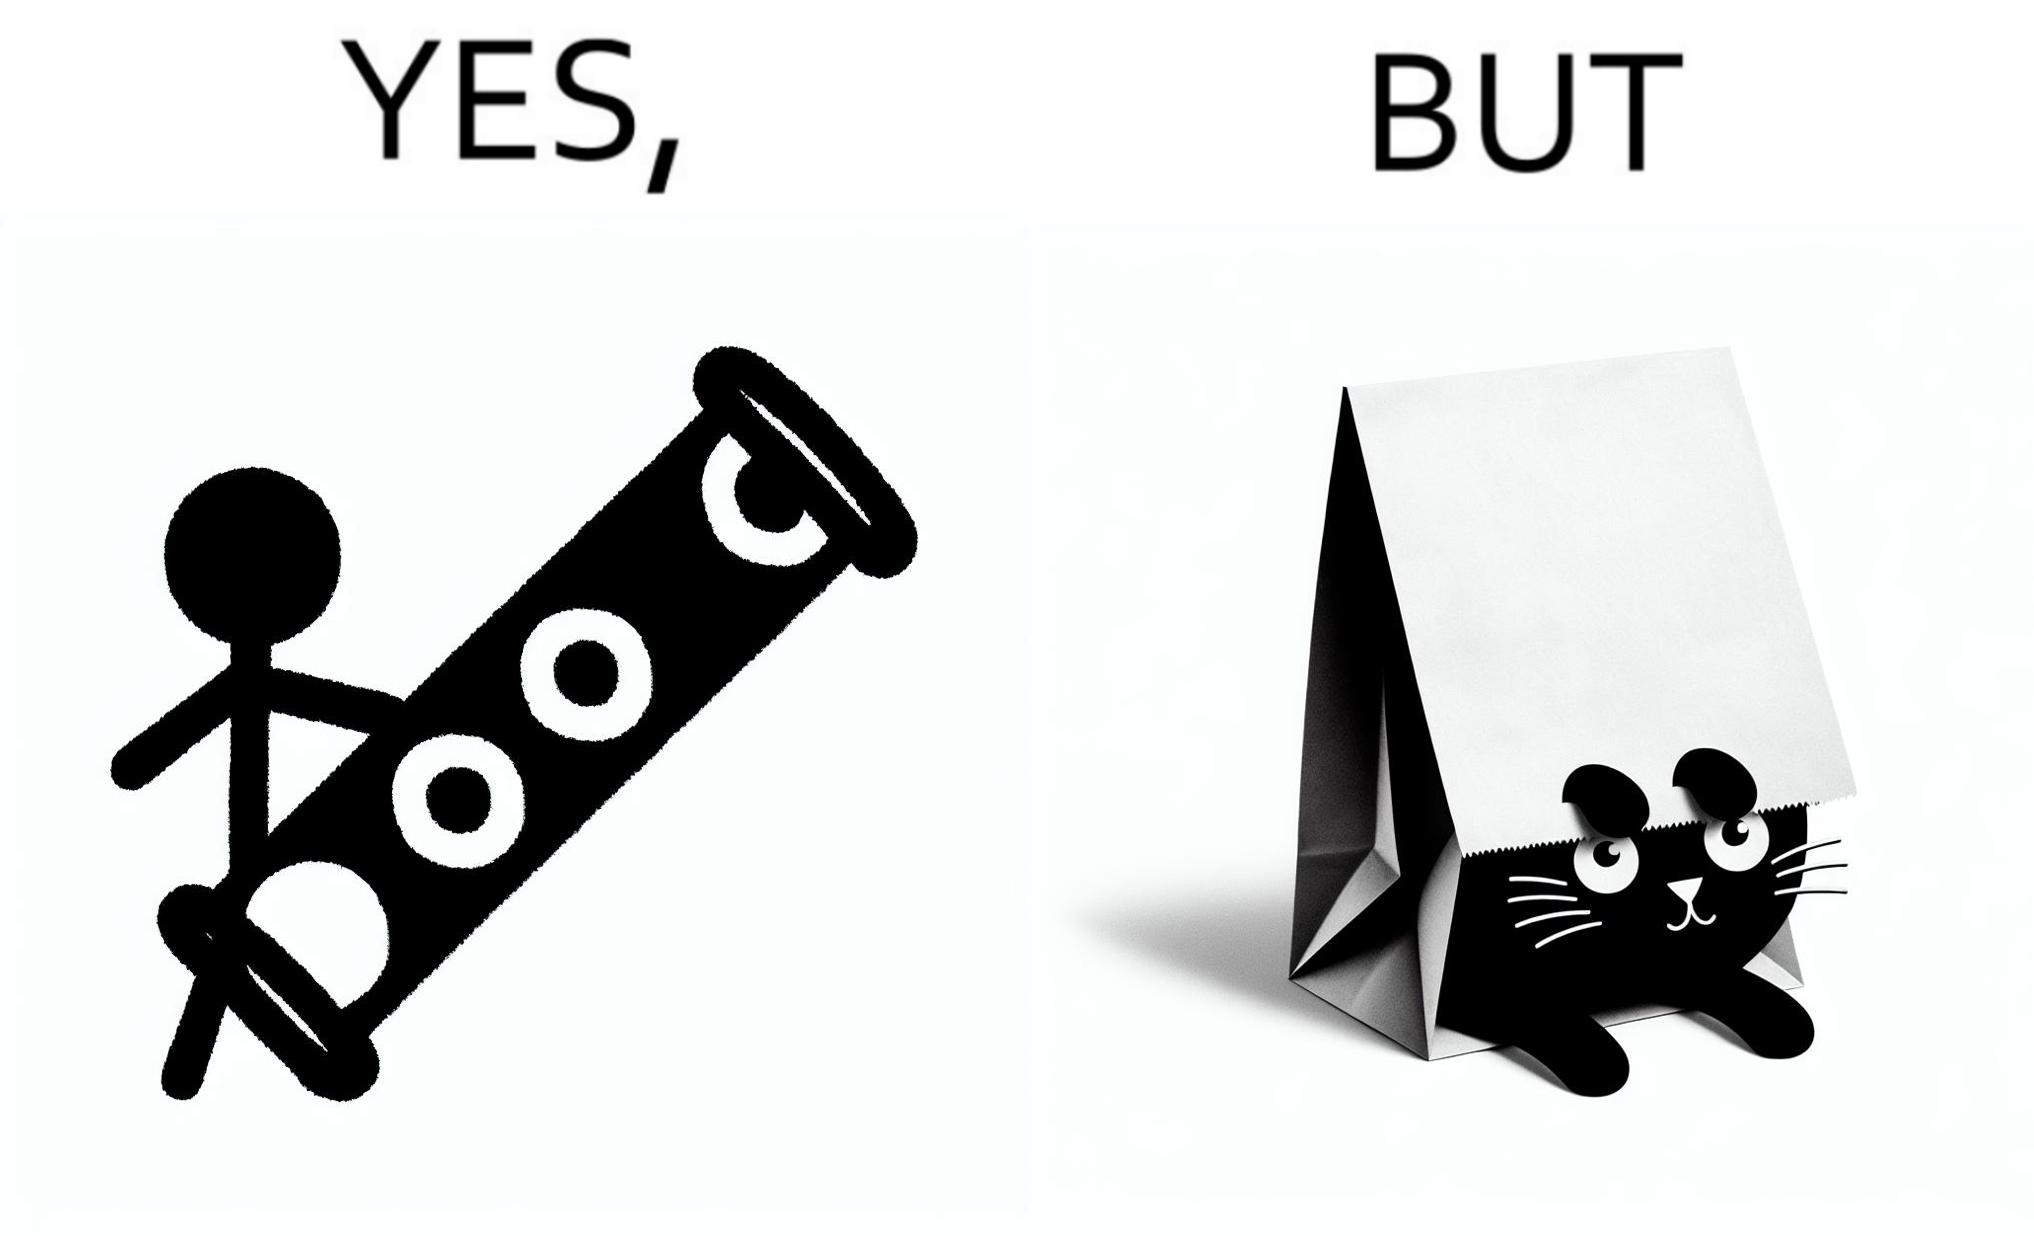Would you classify this image as satirical? Yes, this image is satirical. 